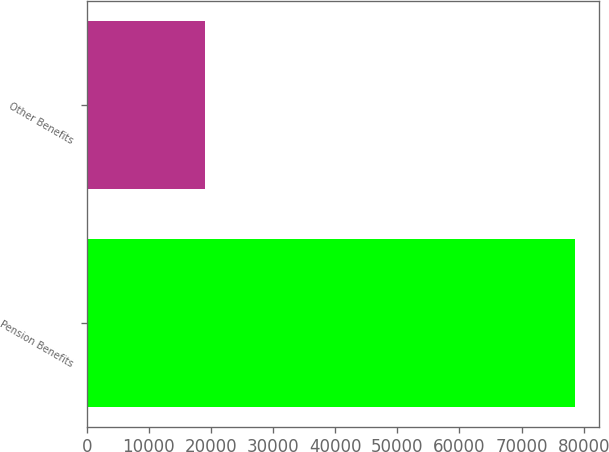Convert chart. <chart><loc_0><loc_0><loc_500><loc_500><bar_chart><fcel>Pension Benefits<fcel>Other Benefits<nl><fcel>78614<fcel>19026<nl></chart> 